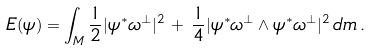<formula> <loc_0><loc_0><loc_500><loc_500>E ( \psi ) = \int _ { M } \frac { 1 } { 2 } | \psi ^ { * } \omega ^ { \perp } | ^ { 2 } \, + \, \frac { 1 } { 4 } | \psi ^ { * } \omega ^ { \perp } \wedge \psi ^ { * } \omega ^ { \perp } | ^ { 2 } \, d m \, .</formula> 